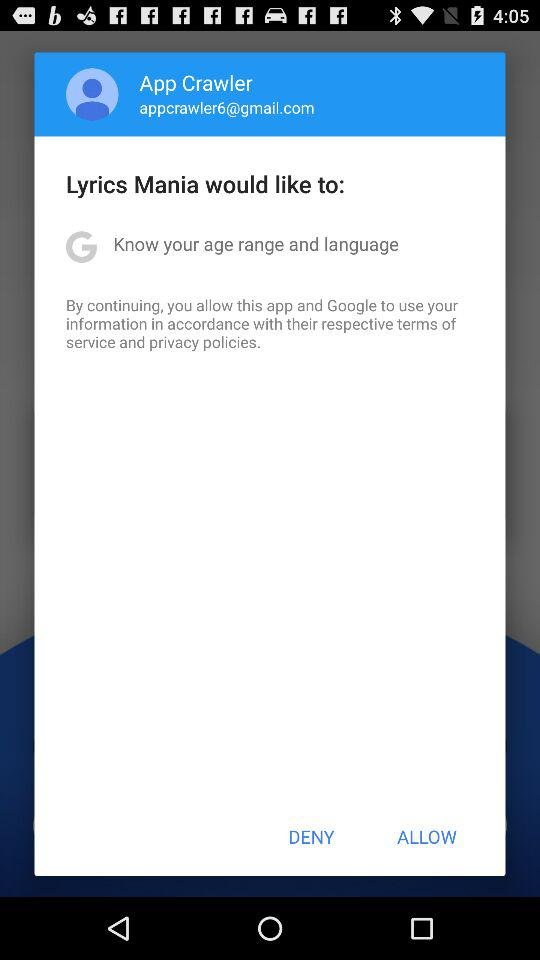Which information would Lyrics Mania like to know? Lyrics Mania would like to know your age range and language. 